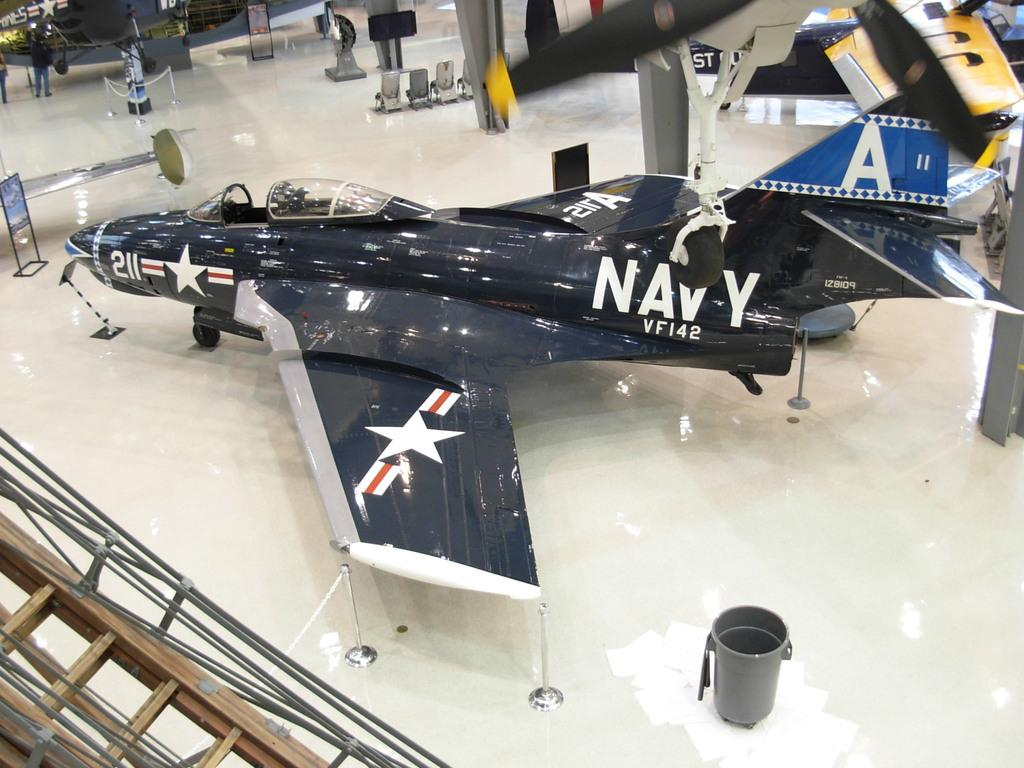<image>
Summarize the visual content of the image. A gleaming blue Navy jet is decorated with several white stars and red and white stripes. 